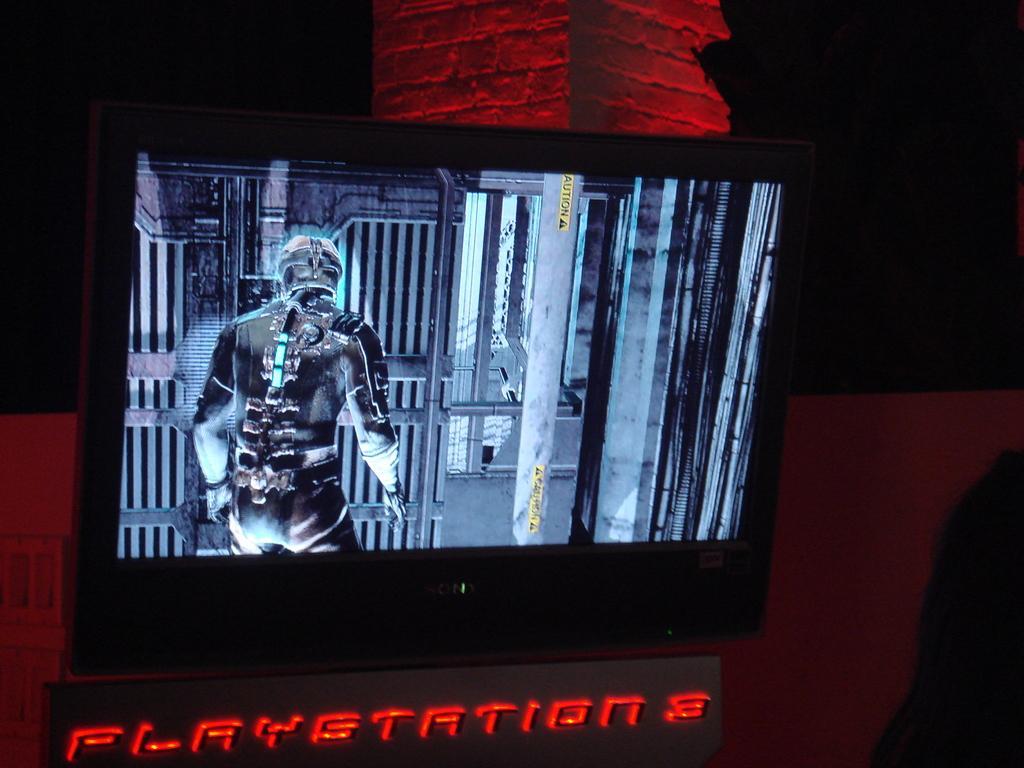What is the main object in the image? There is a display screen in the image. What is shown on the display screen? There is an animated image on the display screen. What type of note is attached to the territory in the image? There is no territory or note present in the image. What tax might be associated with the animated image on the display screen? There is no tax associated with the animated image on the display screen in the image. 